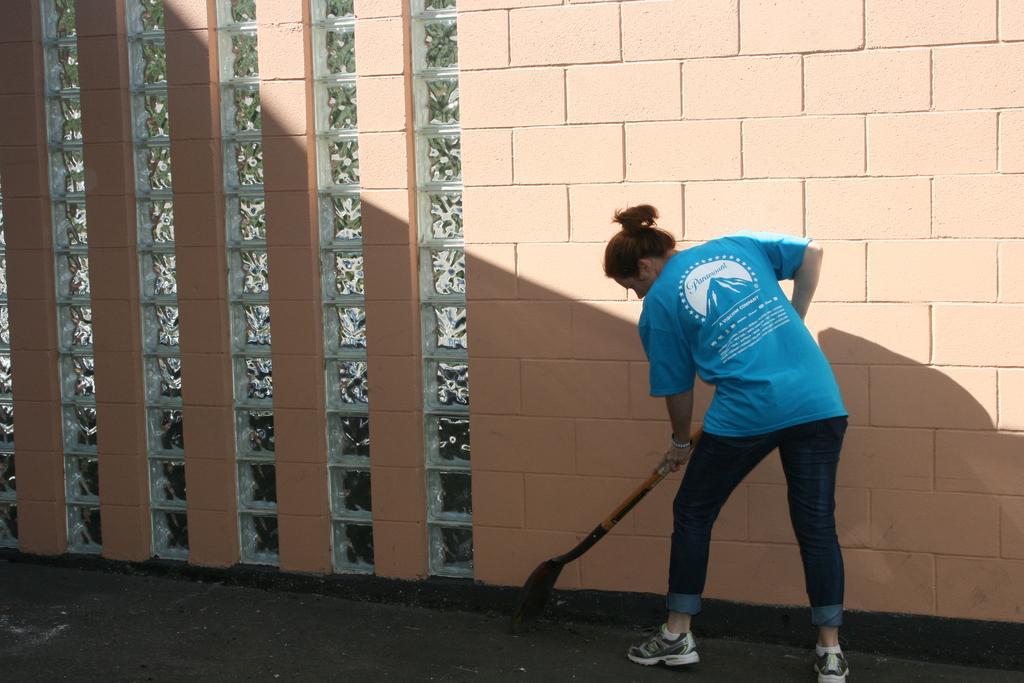Could you give a brief overview of what you see in this image? In this image I can see a person holding something and wearing blue top and jeans. I can see a peach wall. 